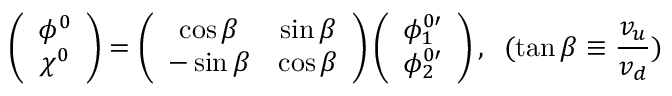Convert formula to latex. <formula><loc_0><loc_0><loc_500><loc_500>\left ( \begin{array} { c } { { \phi ^ { 0 } } } \\ { { \chi ^ { 0 } } } \end{array} \right ) = \left ( \begin{array} { c c } { \cos \beta } & { \sin \beta } \\ { - \sin \beta } & { \cos \beta } \end{array} \right ) \left ( \begin{array} { c } { { \phi _ { 1 } ^ { 0 \prime } } } \\ { { \phi _ { 2 } ^ { 0 \prime } } } \end{array} \right ) , \, ( \tan \beta \equiv \frac { v _ { u } } { v _ { d } } )</formula> 